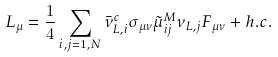Convert formula to latex. <formula><loc_0><loc_0><loc_500><loc_500>L _ { \mu } = \frac { 1 } { 4 } \sum _ { i , j = 1 , N } \bar { \nu } ^ { c } _ { L , i } \sigma _ { \mu \nu } \tilde { \mu } _ { i j } ^ { M } \nu _ { L , j } F _ { \mu \nu } + h . c .</formula> 